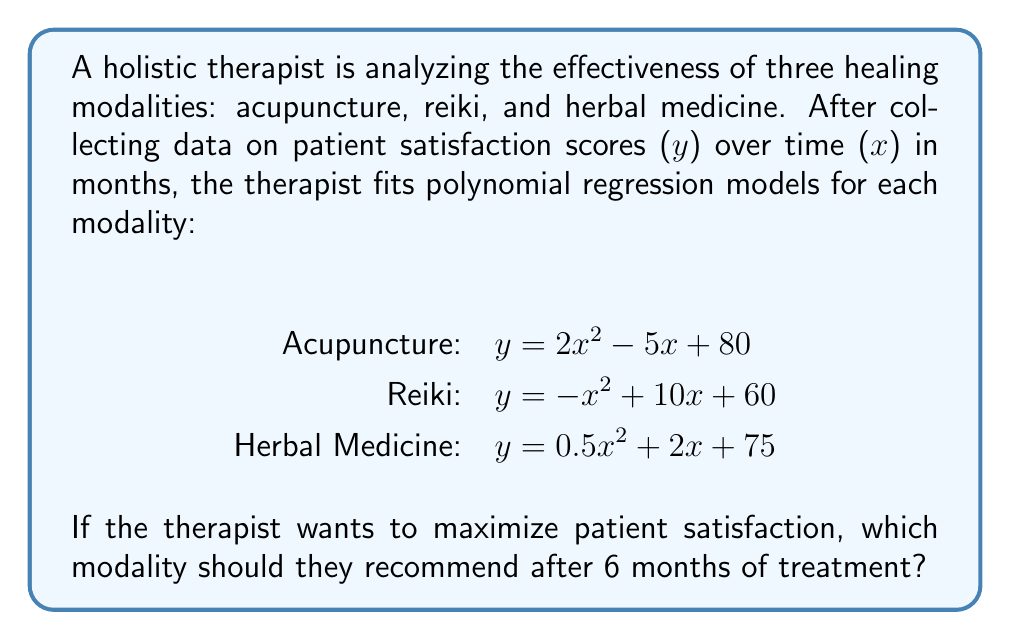Teach me how to tackle this problem. To determine which modality will yield the highest patient satisfaction after 6 months, we need to evaluate each polynomial function at x = 6:

1. Acupuncture: $y = 2x^2 - 5x + 80$
   At x = 6: $y = 2(6)^2 - 5(6) + 80$
           $= 2(36) - 30 + 80$
           $= 72 - 30 + 80$
           $= 122$

2. Reiki: $y = -x^2 + 10x + 60$
   At x = 6: $y = -(6)^2 + 10(6) + 60$
           $= -36 + 60 + 60$
           $= 84$

3. Herbal Medicine: $y = 0.5x^2 + 2x + 75$
   At x = 6: $y = 0.5(6)^2 + 2(6) + 75$
           $= 0.5(36) + 12 + 75$
           $= 18 + 12 + 75$
           $= 105$

Comparing the results:
Acupuncture: 122
Reiki: 84
Herbal Medicine: 105

The highest satisfaction score after 6 months is achieved with Acupuncture.
Answer: Acupuncture 